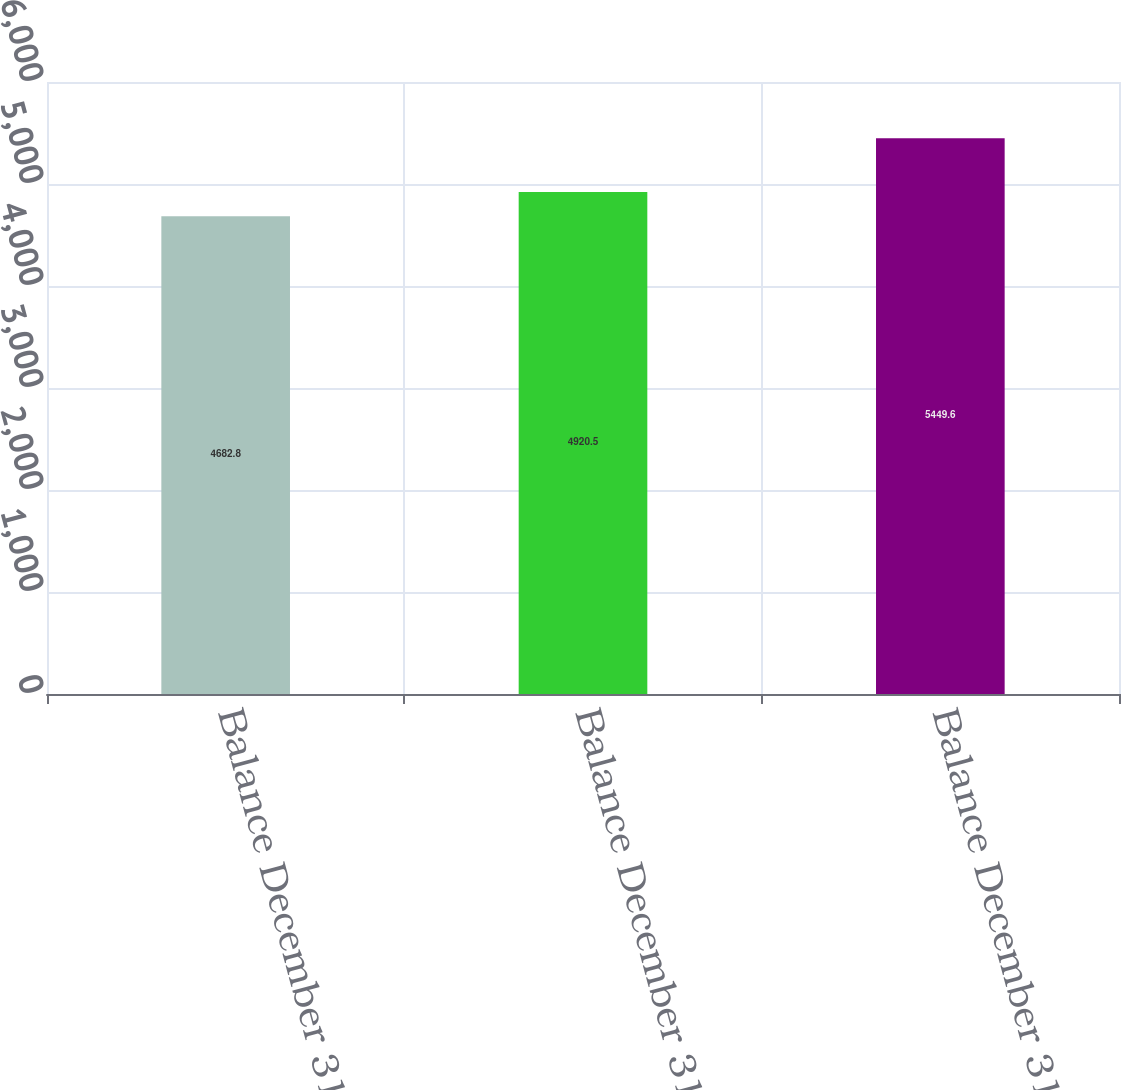Convert chart to OTSL. <chart><loc_0><loc_0><loc_500><loc_500><bar_chart><fcel>Balance December 31 2005<fcel>Balance December 31 2006<fcel>Balance December 31 2007<nl><fcel>4682.8<fcel>4920.5<fcel>5449.6<nl></chart> 